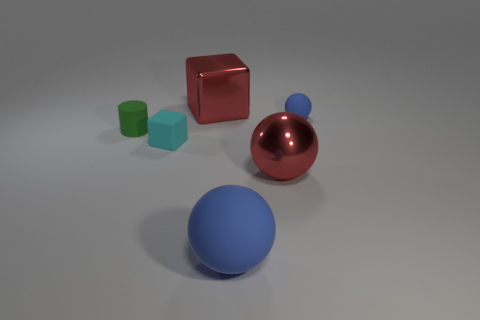What number of big red spheres are there?
Your answer should be compact. 1. What is the shape of the large metal thing that is in front of the big object that is behind the small blue object?
Keep it short and to the point. Sphere. There is a small cyan matte thing; how many red balls are on the right side of it?
Ensure brevity in your answer.  1. Does the cyan block have the same material as the blue object in front of the cylinder?
Offer a terse response. Yes. Are there any other matte cubes of the same size as the cyan block?
Make the answer very short. No. Is the number of large red balls to the left of the green object the same as the number of cyan matte blocks?
Provide a succinct answer. No. The cyan rubber object is what size?
Ensure brevity in your answer.  Small. There is a red object that is on the right side of the large blue matte object; what number of red metallic things are in front of it?
Keep it short and to the point. 0. There is a thing that is left of the large metallic sphere and behind the tiny matte cylinder; what is its shape?
Your response must be concise. Cube. How many matte blocks have the same color as the big shiny block?
Keep it short and to the point. 0. 